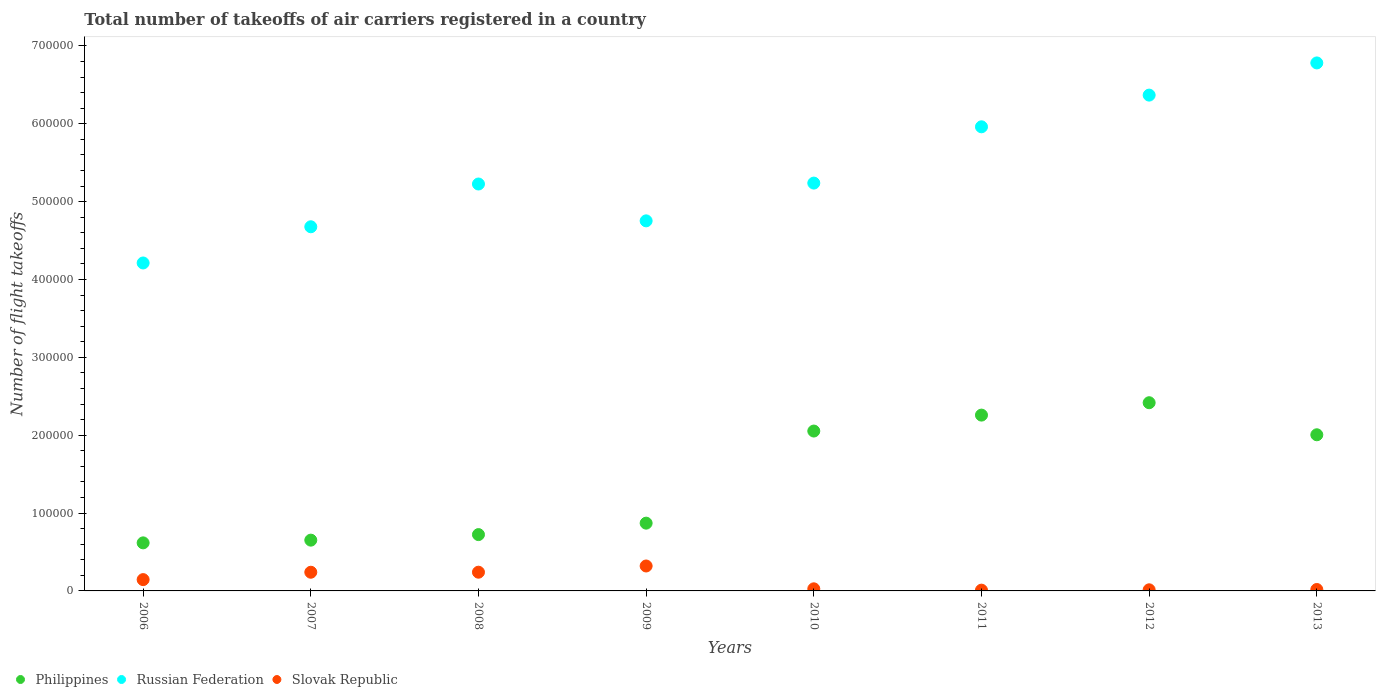How many different coloured dotlines are there?
Provide a succinct answer. 3. What is the total number of flight takeoffs in Philippines in 2013?
Ensure brevity in your answer.  2.01e+05. Across all years, what is the maximum total number of flight takeoffs in Philippines?
Offer a terse response. 2.42e+05. Across all years, what is the minimum total number of flight takeoffs in Slovak Republic?
Ensure brevity in your answer.  990. In which year was the total number of flight takeoffs in Russian Federation minimum?
Give a very brief answer. 2006. What is the total total number of flight takeoffs in Philippines in the graph?
Your response must be concise. 1.16e+06. What is the difference between the total number of flight takeoffs in Russian Federation in 2007 and that in 2009?
Ensure brevity in your answer.  -7591. What is the difference between the total number of flight takeoffs in Philippines in 2011 and the total number of flight takeoffs in Russian Federation in 2007?
Your answer should be compact. -2.42e+05. What is the average total number of flight takeoffs in Philippines per year?
Offer a very short reply. 1.45e+05. In the year 2009, what is the difference between the total number of flight takeoffs in Russian Federation and total number of flight takeoffs in Slovak Republic?
Your response must be concise. 4.43e+05. What is the ratio of the total number of flight takeoffs in Russian Federation in 2006 to that in 2007?
Keep it short and to the point. 0.9. Is the total number of flight takeoffs in Slovak Republic in 2009 less than that in 2013?
Make the answer very short. No. What is the difference between the highest and the second highest total number of flight takeoffs in Philippines?
Give a very brief answer. 1.59e+04. What is the difference between the highest and the lowest total number of flight takeoffs in Russian Federation?
Keep it short and to the point. 2.57e+05. In how many years, is the total number of flight takeoffs in Russian Federation greater than the average total number of flight takeoffs in Russian Federation taken over all years?
Your answer should be very brief. 3. Is it the case that in every year, the sum of the total number of flight takeoffs in Philippines and total number of flight takeoffs in Russian Federation  is greater than the total number of flight takeoffs in Slovak Republic?
Give a very brief answer. Yes. Is the total number of flight takeoffs in Philippines strictly greater than the total number of flight takeoffs in Russian Federation over the years?
Your answer should be very brief. No. Are the values on the major ticks of Y-axis written in scientific E-notation?
Your response must be concise. No. Does the graph contain any zero values?
Give a very brief answer. No. Does the graph contain grids?
Offer a terse response. No. Where does the legend appear in the graph?
Provide a short and direct response. Bottom left. How many legend labels are there?
Give a very brief answer. 3. How are the legend labels stacked?
Your answer should be very brief. Horizontal. What is the title of the graph?
Make the answer very short. Total number of takeoffs of air carriers registered in a country. Does "Papua New Guinea" appear as one of the legend labels in the graph?
Provide a succinct answer. No. What is the label or title of the Y-axis?
Provide a succinct answer. Number of flight takeoffs. What is the Number of flight takeoffs of Philippines in 2006?
Provide a succinct answer. 6.17e+04. What is the Number of flight takeoffs of Russian Federation in 2006?
Provide a succinct answer. 4.21e+05. What is the Number of flight takeoffs of Slovak Republic in 2006?
Keep it short and to the point. 1.45e+04. What is the Number of flight takeoffs in Philippines in 2007?
Provide a succinct answer. 6.52e+04. What is the Number of flight takeoffs in Russian Federation in 2007?
Make the answer very short. 4.68e+05. What is the Number of flight takeoffs of Slovak Republic in 2007?
Your answer should be compact. 2.40e+04. What is the Number of flight takeoffs of Philippines in 2008?
Ensure brevity in your answer.  7.23e+04. What is the Number of flight takeoffs in Russian Federation in 2008?
Keep it short and to the point. 5.23e+05. What is the Number of flight takeoffs of Slovak Republic in 2008?
Ensure brevity in your answer.  2.40e+04. What is the Number of flight takeoffs in Philippines in 2009?
Give a very brief answer. 8.70e+04. What is the Number of flight takeoffs of Russian Federation in 2009?
Provide a short and direct response. 4.75e+05. What is the Number of flight takeoffs of Slovak Republic in 2009?
Provide a succinct answer. 3.20e+04. What is the Number of flight takeoffs in Philippines in 2010?
Offer a very short reply. 2.05e+05. What is the Number of flight takeoffs in Russian Federation in 2010?
Offer a terse response. 5.24e+05. What is the Number of flight takeoffs in Slovak Republic in 2010?
Offer a terse response. 2702. What is the Number of flight takeoffs in Philippines in 2011?
Your response must be concise. 2.26e+05. What is the Number of flight takeoffs in Russian Federation in 2011?
Keep it short and to the point. 5.96e+05. What is the Number of flight takeoffs in Slovak Republic in 2011?
Your answer should be compact. 990. What is the Number of flight takeoffs in Philippines in 2012?
Keep it short and to the point. 2.42e+05. What is the Number of flight takeoffs of Russian Federation in 2012?
Offer a very short reply. 6.37e+05. What is the Number of flight takeoffs in Slovak Republic in 2012?
Make the answer very short. 1439. What is the Number of flight takeoffs in Philippines in 2013?
Provide a short and direct response. 2.01e+05. What is the Number of flight takeoffs in Russian Federation in 2013?
Offer a terse response. 6.78e+05. What is the Number of flight takeoffs in Slovak Republic in 2013?
Keep it short and to the point. 1816.45. Across all years, what is the maximum Number of flight takeoffs in Philippines?
Give a very brief answer. 2.42e+05. Across all years, what is the maximum Number of flight takeoffs of Russian Federation?
Give a very brief answer. 6.78e+05. Across all years, what is the maximum Number of flight takeoffs of Slovak Republic?
Offer a very short reply. 3.20e+04. Across all years, what is the minimum Number of flight takeoffs in Philippines?
Your response must be concise. 6.17e+04. Across all years, what is the minimum Number of flight takeoffs in Russian Federation?
Your response must be concise. 4.21e+05. Across all years, what is the minimum Number of flight takeoffs of Slovak Republic?
Provide a succinct answer. 990. What is the total Number of flight takeoffs in Philippines in the graph?
Your answer should be compact. 1.16e+06. What is the total Number of flight takeoffs of Russian Federation in the graph?
Your answer should be compact. 4.32e+06. What is the total Number of flight takeoffs of Slovak Republic in the graph?
Provide a short and direct response. 1.02e+05. What is the difference between the Number of flight takeoffs of Philippines in 2006 and that in 2007?
Offer a terse response. -3500. What is the difference between the Number of flight takeoffs of Russian Federation in 2006 and that in 2007?
Offer a very short reply. -4.65e+04. What is the difference between the Number of flight takeoffs of Slovak Republic in 2006 and that in 2007?
Offer a very short reply. -9476. What is the difference between the Number of flight takeoffs of Philippines in 2006 and that in 2008?
Make the answer very short. -1.06e+04. What is the difference between the Number of flight takeoffs in Russian Federation in 2006 and that in 2008?
Offer a terse response. -1.01e+05. What is the difference between the Number of flight takeoffs of Slovak Republic in 2006 and that in 2008?
Make the answer very short. -9523. What is the difference between the Number of flight takeoffs of Philippines in 2006 and that in 2009?
Offer a terse response. -2.53e+04. What is the difference between the Number of flight takeoffs of Russian Federation in 2006 and that in 2009?
Ensure brevity in your answer.  -5.41e+04. What is the difference between the Number of flight takeoffs of Slovak Republic in 2006 and that in 2009?
Your answer should be compact. -1.75e+04. What is the difference between the Number of flight takeoffs in Philippines in 2006 and that in 2010?
Make the answer very short. -1.44e+05. What is the difference between the Number of flight takeoffs of Russian Federation in 2006 and that in 2010?
Offer a terse response. -1.03e+05. What is the difference between the Number of flight takeoffs in Slovak Republic in 2006 and that in 2010?
Keep it short and to the point. 1.18e+04. What is the difference between the Number of flight takeoffs of Philippines in 2006 and that in 2011?
Your answer should be very brief. -1.64e+05. What is the difference between the Number of flight takeoffs in Russian Federation in 2006 and that in 2011?
Give a very brief answer. -1.75e+05. What is the difference between the Number of flight takeoffs in Slovak Republic in 2006 and that in 2011?
Your response must be concise. 1.35e+04. What is the difference between the Number of flight takeoffs in Philippines in 2006 and that in 2012?
Ensure brevity in your answer.  -1.80e+05. What is the difference between the Number of flight takeoffs in Russian Federation in 2006 and that in 2012?
Your answer should be compact. -2.16e+05. What is the difference between the Number of flight takeoffs in Slovak Republic in 2006 and that in 2012?
Provide a succinct answer. 1.31e+04. What is the difference between the Number of flight takeoffs in Philippines in 2006 and that in 2013?
Provide a short and direct response. -1.39e+05. What is the difference between the Number of flight takeoffs of Russian Federation in 2006 and that in 2013?
Offer a very short reply. -2.57e+05. What is the difference between the Number of flight takeoffs of Slovak Republic in 2006 and that in 2013?
Give a very brief answer. 1.27e+04. What is the difference between the Number of flight takeoffs in Philippines in 2007 and that in 2008?
Your response must be concise. -7121. What is the difference between the Number of flight takeoffs in Russian Federation in 2007 and that in 2008?
Your response must be concise. -5.49e+04. What is the difference between the Number of flight takeoffs of Slovak Republic in 2007 and that in 2008?
Offer a very short reply. -47. What is the difference between the Number of flight takeoffs in Philippines in 2007 and that in 2009?
Make the answer very short. -2.18e+04. What is the difference between the Number of flight takeoffs in Russian Federation in 2007 and that in 2009?
Offer a terse response. -7591. What is the difference between the Number of flight takeoffs of Slovak Republic in 2007 and that in 2009?
Ensure brevity in your answer.  -8023. What is the difference between the Number of flight takeoffs of Philippines in 2007 and that in 2010?
Ensure brevity in your answer.  -1.40e+05. What is the difference between the Number of flight takeoffs of Russian Federation in 2007 and that in 2010?
Offer a very short reply. -5.61e+04. What is the difference between the Number of flight takeoffs of Slovak Republic in 2007 and that in 2010?
Your answer should be compact. 2.13e+04. What is the difference between the Number of flight takeoffs in Philippines in 2007 and that in 2011?
Keep it short and to the point. -1.61e+05. What is the difference between the Number of flight takeoffs in Russian Federation in 2007 and that in 2011?
Your answer should be very brief. -1.28e+05. What is the difference between the Number of flight takeoffs in Slovak Republic in 2007 and that in 2011?
Keep it short and to the point. 2.30e+04. What is the difference between the Number of flight takeoffs in Philippines in 2007 and that in 2012?
Offer a terse response. -1.76e+05. What is the difference between the Number of flight takeoffs of Russian Federation in 2007 and that in 2012?
Ensure brevity in your answer.  -1.69e+05. What is the difference between the Number of flight takeoffs of Slovak Republic in 2007 and that in 2012?
Give a very brief answer. 2.26e+04. What is the difference between the Number of flight takeoffs of Philippines in 2007 and that in 2013?
Give a very brief answer. -1.35e+05. What is the difference between the Number of flight takeoffs in Russian Federation in 2007 and that in 2013?
Give a very brief answer. -2.10e+05. What is the difference between the Number of flight takeoffs in Slovak Republic in 2007 and that in 2013?
Provide a short and direct response. 2.22e+04. What is the difference between the Number of flight takeoffs of Philippines in 2008 and that in 2009?
Your answer should be very brief. -1.47e+04. What is the difference between the Number of flight takeoffs in Russian Federation in 2008 and that in 2009?
Offer a very short reply. 4.73e+04. What is the difference between the Number of flight takeoffs in Slovak Republic in 2008 and that in 2009?
Provide a succinct answer. -7976. What is the difference between the Number of flight takeoffs in Philippines in 2008 and that in 2010?
Provide a short and direct response. -1.33e+05. What is the difference between the Number of flight takeoffs in Russian Federation in 2008 and that in 2010?
Make the answer very short. -1182. What is the difference between the Number of flight takeoffs of Slovak Republic in 2008 and that in 2010?
Ensure brevity in your answer.  2.13e+04. What is the difference between the Number of flight takeoffs of Philippines in 2008 and that in 2011?
Ensure brevity in your answer.  -1.53e+05. What is the difference between the Number of flight takeoffs of Russian Federation in 2008 and that in 2011?
Offer a very short reply. -7.35e+04. What is the difference between the Number of flight takeoffs of Slovak Republic in 2008 and that in 2011?
Offer a very short reply. 2.31e+04. What is the difference between the Number of flight takeoffs of Philippines in 2008 and that in 2012?
Provide a succinct answer. -1.69e+05. What is the difference between the Number of flight takeoffs of Russian Federation in 2008 and that in 2012?
Your response must be concise. -1.14e+05. What is the difference between the Number of flight takeoffs of Slovak Republic in 2008 and that in 2012?
Offer a terse response. 2.26e+04. What is the difference between the Number of flight takeoffs of Philippines in 2008 and that in 2013?
Give a very brief answer. -1.28e+05. What is the difference between the Number of flight takeoffs in Russian Federation in 2008 and that in 2013?
Give a very brief answer. -1.55e+05. What is the difference between the Number of flight takeoffs of Slovak Republic in 2008 and that in 2013?
Provide a short and direct response. 2.22e+04. What is the difference between the Number of flight takeoffs of Philippines in 2009 and that in 2010?
Your answer should be compact. -1.18e+05. What is the difference between the Number of flight takeoffs of Russian Federation in 2009 and that in 2010?
Offer a terse response. -4.85e+04. What is the difference between the Number of flight takeoffs of Slovak Republic in 2009 and that in 2010?
Your response must be concise. 2.93e+04. What is the difference between the Number of flight takeoffs in Philippines in 2009 and that in 2011?
Make the answer very short. -1.39e+05. What is the difference between the Number of flight takeoffs in Russian Federation in 2009 and that in 2011?
Provide a succinct answer. -1.21e+05. What is the difference between the Number of flight takeoffs in Slovak Republic in 2009 and that in 2011?
Make the answer very short. 3.10e+04. What is the difference between the Number of flight takeoffs in Philippines in 2009 and that in 2012?
Keep it short and to the point. -1.55e+05. What is the difference between the Number of flight takeoffs in Russian Federation in 2009 and that in 2012?
Provide a succinct answer. -1.61e+05. What is the difference between the Number of flight takeoffs in Slovak Republic in 2009 and that in 2012?
Your response must be concise. 3.06e+04. What is the difference between the Number of flight takeoffs in Philippines in 2009 and that in 2013?
Give a very brief answer. -1.14e+05. What is the difference between the Number of flight takeoffs in Russian Federation in 2009 and that in 2013?
Your answer should be very brief. -2.03e+05. What is the difference between the Number of flight takeoffs of Slovak Republic in 2009 and that in 2013?
Offer a terse response. 3.02e+04. What is the difference between the Number of flight takeoffs of Philippines in 2010 and that in 2011?
Your answer should be compact. -2.05e+04. What is the difference between the Number of flight takeoffs in Russian Federation in 2010 and that in 2011?
Make the answer very short. -7.23e+04. What is the difference between the Number of flight takeoffs of Slovak Republic in 2010 and that in 2011?
Offer a terse response. 1712. What is the difference between the Number of flight takeoffs of Philippines in 2010 and that in 2012?
Keep it short and to the point. -3.64e+04. What is the difference between the Number of flight takeoffs of Russian Federation in 2010 and that in 2012?
Provide a short and direct response. -1.13e+05. What is the difference between the Number of flight takeoffs in Slovak Republic in 2010 and that in 2012?
Provide a succinct answer. 1263. What is the difference between the Number of flight takeoffs in Philippines in 2010 and that in 2013?
Make the answer very short. 4782.3. What is the difference between the Number of flight takeoffs in Russian Federation in 2010 and that in 2013?
Your answer should be very brief. -1.54e+05. What is the difference between the Number of flight takeoffs of Slovak Republic in 2010 and that in 2013?
Provide a short and direct response. 885.55. What is the difference between the Number of flight takeoffs in Philippines in 2011 and that in 2012?
Your answer should be very brief. -1.59e+04. What is the difference between the Number of flight takeoffs of Russian Federation in 2011 and that in 2012?
Make the answer very short. -4.07e+04. What is the difference between the Number of flight takeoffs of Slovak Republic in 2011 and that in 2012?
Offer a very short reply. -449. What is the difference between the Number of flight takeoffs of Philippines in 2011 and that in 2013?
Your response must be concise. 2.53e+04. What is the difference between the Number of flight takeoffs of Russian Federation in 2011 and that in 2013?
Your answer should be compact. -8.20e+04. What is the difference between the Number of flight takeoffs in Slovak Republic in 2011 and that in 2013?
Provide a short and direct response. -826.45. What is the difference between the Number of flight takeoffs in Philippines in 2012 and that in 2013?
Provide a short and direct response. 4.12e+04. What is the difference between the Number of flight takeoffs in Russian Federation in 2012 and that in 2013?
Offer a very short reply. -4.13e+04. What is the difference between the Number of flight takeoffs in Slovak Republic in 2012 and that in 2013?
Keep it short and to the point. -377.45. What is the difference between the Number of flight takeoffs of Philippines in 2006 and the Number of flight takeoffs of Russian Federation in 2007?
Your answer should be compact. -4.06e+05. What is the difference between the Number of flight takeoffs of Philippines in 2006 and the Number of flight takeoffs of Slovak Republic in 2007?
Offer a terse response. 3.77e+04. What is the difference between the Number of flight takeoffs in Russian Federation in 2006 and the Number of flight takeoffs in Slovak Republic in 2007?
Your answer should be very brief. 3.97e+05. What is the difference between the Number of flight takeoffs of Philippines in 2006 and the Number of flight takeoffs of Russian Federation in 2008?
Your response must be concise. -4.61e+05. What is the difference between the Number of flight takeoffs in Philippines in 2006 and the Number of flight takeoffs in Slovak Republic in 2008?
Give a very brief answer. 3.77e+04. What is the difference between the Number of flight takeoffs of Russian Federation in 2006 and the Number of flight takeoffs of Slovak Republic in 2008?
Provide a succinct answer. 3.97e+05. What is the difference between the Number of flight takeoffs of Philippines in 2006 and the Number of flight takeoffs of Russian Federation in 2009?
Your response must be concise. -4.14e+05. What is the difference between the Number of flight takeoffs in Philippines in 2006 and the Number of flight takeoffs in Slovak Republic in 2009?
Your answer should be very brief. 2.97e+04. What is the difference between the Number of flight takeoffs of Russian Federation in 2006 and the Number of flight takeoffs of Slovak Republic in 2009?
Make the answer very short. 3.89e+05. What is the difference between the Number of flight takeoffs of Philippines in 2006 and the Number of flight takeoffs of Russian Federation in 2010?
Offer a very short reply. -4.62e+05. What is the difference between the Number of flight takeoffs of Philippines in 2006 and the Number of flight takeoffs of Slovak Republic in 2010?
Provide a short and direct response. 5.90e+04. What is the difference between the Number of flight takeoffs of Russian Federation in 2006 and the Number of flight takeoffs of Slovak Republic in 2010?
Ensure brevity in your answer.  4.18e+05. What is the difference between the Number of flight takeoffs of Philippines in 2006 and the Number of flight takeoffs of Russian Federation in 2011?
Your answer should be compact. -5.34e+05. What is the difference between the Number of flight takeoffs of Philippines in 2006 and the Number of flight takeoffs of Slovak Republic in 2011?
Your answer should be compact. 6.07e+04. What is the difference between the Number of flight takeoffs of Russian Federation in 2006 and the Number of flight takeoffs of Slovak Republic in 2011?
Your answer should be very brief. 4.20e+05. What is the difference between the Number of flight takeoffs in Philippines in 2006 and the Number of flight takeoffs in Russian Federation in 2012?
Offer a very short reply. -5.75e+05. What is the difference between the Number of flight takeoffs in Philippines in 2006 and the Number of flight takeoffs in Slovak Republic in 2012?
Ensure brevity in your answer.  6.03e+04. What is the difference between the Number of flight takeoffs in Russian Federation in 2006 and the Number of flight takeoffs in Slovak Republic in 2012?
Your answer should be compact. 4.20e+05. What is the difference between the Number of flight takeoffs in Philippines in 2006 and the Number of flight takeoffs in Russian Federation in 2013?
Provide a succinct answer. -6.16e+05. What is the difference between the Number of flight takeoffs of Philippines in 2006 and the Number of flight takeoffs of Slovak Republic in 2013?
Give a very brief answer. 5.99e+04. What is the difference between the Number of flight takeoffs of Russian Federation in 2006 and the Number of flight takeoffs of Slovak Republic in 2013?
Offer a terse response. 4.19e+05. What is the difference between the Number of flight takeoffs of Philippines in 2007 and the Number of flight takeoffs of Russian Federation in 2008?
Your response must be concise. -4.57e+05. What is the difference between the Number of flight takeoffs in Philippines in 2007 and the Number of flight takeoffs in Slovak Republic in 2008?
Provide a succinct answer. 4.12e+04. What is the difference between the Number of flight takeoffs in Russian Federation in 2007 and the Number of flight takeoffs in Slovak Republic in 2008?
Your response must be concise. 4.44e+05. What is the difference between the Number of flight takeoffs in Philippines in 2007 and the Number of flight takeoffs in Russian Federation in 2009?
Your answer should be very brief. -4.10e+05. What is the difference between the Number of flight takeoffs in Philippines in 2007 and the Number of flight takeoffs in Slovak Republic in 2009?
Your response must be concise. 3.32e+04. What is the difference between the Number of flight takeoffs of Russian Federation in 2007 and the Number of flight takeoffs of Slovak Republic in 2009?
Give a very brief answer. 4.36e+05. What is the difference between the Number of flight takeoffs in Philippines in 2007 and the Number of flight takeoffs in Russian Federation in 2010?
Ensure brevity in your answer.  -4.59e+05. What is the difference between the Number of flight takeoffs in Philippines in 2007 and the Number of flight takeoffs in Slovak Republic in 2010?
Offer a very short reply. 6.25e+04. What is the difference between the Number of flight takeoffs of Russian Federation in 2007 and the Number of flight takeoffs of Slovak Republic in 2010?
Keep it short and to the point. 4.65e+05. What is the difference between the Number of flight takeoffs in Philippines in 2007 and the Number of flight takeoffs in Russian Federation in 2011?
Provide a short and direct response. -5.31e+05. What is the difference between the Number of flight takeoffs in Philippines in 2007 and the Number of flight takeoffs in Slovak Republic in 2011?
Ensure brevity in your answer.  6.42e+04. What is the difference between the Number of flight takeoffs of Russian Federation in 2007 and the Number of flight takeoffs of Slovak Republic in 2011?
Provide a succinct answer. 4.67e+05. What is the difference between the Number of flight takeoffs in Philippines in 2007 and the Number of flight takeoffs in Russian Federation in 2012?
Offer a very short reply. -5.72e+05. What is the difference between the Number of flight takeoffs of Philippines in 2007 and the Number of flight takeoffs of Slovak Republic in 2012?
Provide a short and direct response. 6.38e+04. What is the difference between the Number of flight takeoffs of Russian Federation in 2007 and the Number of flight takeoffs of Slovak Republic in 2012?
Provide a short and direct response. 4.66e+05. What is the difference between the Number of flight takeoffs of Philippines in 2007 and the Number of flight takeoffs of Russian Federation in 2013?
Your answer should be very brief. -6.13e+05. What is the difference between the Number of flight takeoffs in Philippines in 2007 and the Number of flight takeoffs in Slovak Republic in 2013?
Provide a succinct answer. 6.34e+04. What is the difference between the Number of flight takeoffs of Russian Federation in 2007 and the Number of flight takeoffs of Slovak Republic in 2013?
Provide a succinct answer. 4.66e+05. What is the difference between the Number of flight takeoffs in Philippines in 2008 and the Number of flight takeoffs in Russian Federation in 2009?
Your response must be concise. -4.03e+05. What is the difference between the Number of flight takeoffs of Philippines in 2008 and the Number of flight takeoffs of Slovak Republic in 2009?
Your response must be concise. 4.03e+04. What is the difference between the Number of flight takeoffs in Russian Federation in 2008 and the Number of flight takeoffs in Slovak Republic in 2009?
Make the answer very short. 4.91e+05. What is the difference between the Number of flight takeoffs in Philippines in 2008 and the Number of flight takeoffs in Russian Federation in 2010?
Your answer should be compact. -4.51e+05. What is the difference between the Number of flight takeoffs in Philippines in 2008 and the Number of flight takeoffs in Slovak Republic in 2010?
Give a very brief answer. 6.96e+04. What is the difference between the Number of flight takeoffs in Russian Federation in 2008 and the Number of flight takeoffs in Slovak Republic in 2010?
Offer a terse response. 5.20e+05. What is the difference between the Number of flight takeoffs in Philippines in 2008 and the Number of flight takeoffs in Russian Federation in 2011?
Offer a terse response. -5.24e+05. What is the difference between the Number of flight takeoffs of Philippines in 2008 and the Number of flight takeoffs of Slovak Republic in 2011?
Offer a very short reply. 7.13e+04. What is the difference between the Number of flight takeoffs in Russian Federation in 2008 and the Number of flight takeoffs in Slovak Republic in 2011?
Your answer should be compact. 5.22e+05. What is the difference between the Number of flight takeoffs in Philippines in 2008 and the Number of flight takeoffs in Russian Federation in 2012?
Offer a terse response. -5.64e+05. What is the difference between the Number of flight takeoffs of Philippines in 2008 and the Number of flight takeoffs of Slovak Republic in 2012?
Keep it short and to the point. 7.09e+04. What is the difference between the Number of flight takeoffs of Russian Federation in 2008 and the Number of flight takeoffs of Slovak Republic in 2012?
Provide a succinct answer. 5.21e+05. What is the difference between the Number of flight takeoffs of Philippines in 2008 and the Number of flight takeoffs of Russian Federation in 2013?
Provide a short and direct response. -6.06e+05. What is the difference between the Number of flight takeoffs in Philippines in 2008 and the Number of flight takeoffs in Slovak Republic in 2013?
Your response must be concise. 7.05e+04. What is the difference between the Number of flight takeoffs in Russian Federation in 2008 and the Number of flight takeoffs in Slovak Republic in 2013?
Your response must be concise. 5.21e+05. What is the difference between the Number of flight takeoffs in Philippines in 2009 and the Number of flight takeoffs in Russian Federation in 2010?
Provide a short and direct response. -4.37e+05. What is the difference between the Number of flight takeoffs of Philippines in 2009 and the Number of flight takeoffs of Slovak Republic in 2010?
Your answer should be very brief. 8.43e+04. What is the difference between the Number of flight takeoffs of Russian Federation in 2009 and the Number of flight takeoffs of Slovak Republic in 2010?
Your answer should be compact. 4.73e+05. What is the difference between the Number of flight takeoffs in Philippines in 2009 and the Number of flight takeoffs in Russian Federation in 2011?
Your answer should be compact. -5.09e+05. What is the difference between the Number of flight takeoffs of Philippines in 2009 and the Number of flight takeoffs of Slovak Republic in 2011?
Offer a very short reply. 8.60e+04. What is the difference between the Number of flight takeoffs in Russian Federation in 2009 and the Number of flight takeoffs in Slovak Republic in 2011?
Your answer should be very brief. 4.74e+05. What is the difference between the Number of flight takeoffs of Philippines in 2009 and the Number of flight takeoffs of Russian Federation in 2012?
Provide a short and direct response. -5.50e+05. What is the difference between the Number of flight takeoffs of Philippines in 2009 and the Number of flight takeoffs of Slovak Republic in 2012?
Provide a short and direct response. 8.56e+04. What is the difference between the Number of flight takeoffs of Russian Federation in 2009 and the Number of flight takeoffs of Slovak Republic in 2012?
Your answer should be very brief. 4.74e+05. What is the difference between the Number of flight takeoffs in Philippines in 2009 and the Number of flight takeoffs in Russian Federation in 2013?
Provide a succinct answer. -5.91e+05. What is the difference between the Number of flight takeoffs in Philippines in 2009 and the Number of flight takeoffs in Slovak Republic in 2013?
Offer a terse response. 8.52e+04. What is the difference between the Number of flight takeoffs in Russian Federation in 2009 and the Number of flight takeoffs in Slovak Republic in 2013?
Your answer should be very brief. 4.73e+05. What is the difference between the Number of flight takeoffs of Philippines in 2010 and the Number of flight takeoffs of Russian Federation in 2011?
Provide a short and direct response. -3.91e+05. What is the difference between the Number of flight takeoffs in Philippines in 2010 and the Number of flight takeoffs in Slovak Republic in 2011?
Your answer should be very brief. 2.04e+05. What is the difference between the Number of flight takeoffs of Russian Federation in 2010 and the Number of flight takeoffs of Slovak Republic in 2011?
Keep it short and to the point. 5.23e+05. What is the difference between the Number of flight takeoffs in Philippines in 2010 and the Number of flight takeoffs in Russian Federation in 2012?
Provide a short and direct response. -4.31e+05. What is the difference between the Number of flight takeoffs of Philippines in 2010 and the Number of flight takeoffs of Slovak Republic in 2012?
Your answer should be compact. 2.04e+05. What is the difference between the Number of flight takeoffs in Russian Federation in 2010 and the Number of flight takeoffs in Slovak Republic in 2012?
Your answer should be compact. 5.22e+05. What is the difference between the Number of flight takeoffs of Philippines in 2010 and the Number of flight takeoffs of Russian Federation in 2013?
Your response must be concise. -4.73e+05. What is the difference between the Number of flight takeoffs in Philippines in 2010 and the Number of flight takeoffs in Slovak Republic in 2013?
Provide a short and direct response. 2.04e+05. What is the difference between the Number of flight takeoffs of Russian Federation in 2010 and the Number of flight takeoffs of Slovak Republic in 2013?
Offer a terse response. 5.22e+05. What is the difference between the Number of flight takeoffs in Philippines in 2011 and the Number of flight takeoffs in Russian Federation in 2012?
Make the answer very short. -4.11e+05. What is the difference between the Number of flight takeoffs in Philippines in 2011 and the Number of flight takeoffs in Slovak Republic in 2012?
Make the answer very short. 2.24e+05. What is the difference between the Number of flight takeoffs in Russian Federation in 2011 and the Number of flight takeoffs in Slovak Republic in 2012?
Ensure brevity in your answer.  5.95e+05. What is the difference between the Number of flight takeoffs of Philippines in 2011 and the Number of flight takeoffs of Russian Federation in 2013?
Provide a short and direct response. -4.52e+05. What is the difference between the Number of flight takeoffs in Philippines in 2011 and the Number of flight takeoffs in Slovak Republic in 2013?
Offer a very short reply. 2.24e+05. What is the difference between the Number of flight takeoffs in Russian Federation in 2011 and the Number of flight takeoffs in Slovak Republic in 2013?
Offer a terse response. 5.94e+05. What is the difference between the Number of flight takeoffs in Philippines in 2012 and the Number of flight takeoffs in Russian Federation in 2013?
Keep it short and to the point. -4.36e+05. What is the difference between the Number of flight takeoffs in Philippines in 2012 and the Number of flight takeoffs in Slovak Republic in 2013?
Provide a short and direct response. 2.40e+05. What is the difference between the Number of flight takeoffs of Russian Federation in 2012 and the Number of flight takeoffs of Slovak Republic in 2013?
Keep it short and to the point. 6.35e+05. What is the average Number of flight takeoffs in Philippines per year?
Your answer should be very brief. 1.45e+05. What is the average Number of flight takeoffs of Russian Federation per year?
Your answer should be compact. 5.40e+05. What is the average Number of flight takeoffs of Slovak Republic per year?
Your answer should be compact. 1.27e+04. In the year 2006, what is the difference between the Number of flight takeoffs of Philippines and Number of flight takeoffs of Russian Federation?
Offer a very short reply. -3.59e+05. In the year 2006, what is the difference between the Number of flight takeoffs of Philippines and Number of flight takeoffs of Slovak Republic?
Make the answer very short. 4.72e+04. In the year 2006, what is the difference between the Number of flight takeoffs of Russian Federation and Number of flight takeoffs of Slovak Republic?
Give a very brief answer. 4.07e+05. In the year 2007, what is the difference between the Number of flight takeoffs of Philippines and Number of flight takeoffs of Russian Federation?
Your answer should be compact. -4.02e+05. In the year 2007, what is the difference between the Number of flight takeoffs in Philippines and Number of flight takeoffs in Slovak Republic?
Keep it short and to the point. 4.12e+04. In the year 2007, what is the difference between the Number of flight takeoffs of Russian Federation and Number of flight takeoffs of Slovak Republic?
Keep it short and to the point. 4.44e+05. In the year 2008, what is the difference between the Number of flight takeoffs in Philippines and Number of flight takeoffs in Russian Federation?
Ensure brevity in your answer.  -4.50e+05. In the year 2008, what is the difference between the Number of flight takeoffs of Philippines and Number of flight takeoffs of Slovak Republic?
Your answer should be compact. 4.83e+04. In the year 2008, what is the difference between the Number of flight takeoffs in Russian Federation and Number of flight takeoffs in Slovak Republic?
Your answer should be compact. 4.99e+05. In the year 2009, what is the difference between the Number of flight takeoffs in Philippines and Number of flight takeoffs in Russian Federation?
Make the answer very short. -3.88e+05. In the year 2009, what is the difference between the Number of flight takeoffs in Philippines and Number of flight takeoffs in Slovak Republic?
Provide a short and direct response. 5.50e+04. In the year 2009, what is the difference between the Number of flight takeoffs of Russian Federation and Number of flight takeoffs of Slovak Republic?
Offer a terse response. 4.43e+05. In the year 2010, what is the difference between the Number of flight takeoffs of Philippines and Number of flight takeoffs of Russian Federation?
Your response must be concise. -3.18e+05. In the year 2010, what is the difference between the Number of flight takeoffs of Philippines and Number of flight takeoffs of Slovak Republic?
Provide a succinct answer. 2.03e+05. In the year 2010, what is the difference between the Number of flight takeoffs in Russian Federation and Number of flight takeoffs in Slovak Republic?
Your answer should be compact. 5.21e+05. In the year 2011, what is the difference between the Number of flight takeoffs of Philippines and Number of flight takeoffs of Russian Federation?
Offer a terse response. -3.70e+05. In the year 2011, what is the difference between the Number of flight takeoffs of Philippines and Number of flight takeoffs of Slovak Republic?
Keep it short and to the point. 2.25e+05. In the year 2011, what is the difference between the Number of flight takeoffs in Russian Federation and Number of flight takeoffs in Slovak Republic?
Your answer should be very brief. 5.95e+05. In the year 2012, what is the difference between the Number of flight takeoffs of Philippines and Number of flight takeoffs of Russian Federation?
Your answer should be very brief. -3.95e+05. In the year 2012, what is the difference between the Number of flight takeoffs of Philippines and Number of flight takeoffs of Slovak Republic?
Make the answer very short. 2.40e+05. In the year 2012, what is the difference between the Number of flight takeoffs of Russian Federation and Number of flight takeoffs of Slovak Republic?
Offer a very short reply. 6.35e+05. In the year 2013, what is the difference between the Number of flight takeoffs of Philippines and Number of flight takeoffs of Russian Federation?
Offer a terse response. -4.78e+05. In the year 2013, what is the difference between the Number of flight takeoffs of Philippines and Number of flight takeoffs of Slovak Republic?
Give a very brief answer. 1.99e+05. In the year 2013, what is the difference between the Number of flight takeoffs of Russian Federation and Number of flight takeoffs of Slovak Republic?
Your answer should be compact. 6.76e+05. What is the ratio of the Number of flight takeoffs in Philippines in 2006 to that in 2007?
Provide a succinct answer. 0.95. What is the ratio of the Number of flight takeoffs of Russian Federation in 2006 to that in 2007?
Give a very brief answer. 0.9. What is the ratio of the Number of flight takeoffs in Slovak Republic in 2006 to that in 2007?
Provide a succinct answer. 0.61. What is the ratio of the Number of flight takeoffs in Philippines in 2006 to that in 2008?
Your answer should be compact. 0.85. What is the ratio of the Number of flight takeoffs of Russian Federation in 2006 to that in 2008?
Your answer should be very brief. 0.81. What is the ratio of the Number of flight takeoffs of Slovak Republic in 2006 to that in 2008?
Your answer should be very brief. 0.6. What is the ratio of the Number of flight takeoffs of Philippines in 2006 to that in 2009?
Your answer should be compact. 0.71. What is the ratio of the Number of flight takeoffs in Russian Federation in 2006 to that in 2009?
Offer a very short reply. 0.89. What is the ratio of the Number of flight takeoffs in Slovak Republic in 2006 to that in 2009?
Ensure brevity in your answer.  0.45. What is the ratio of the Number of flight takeoffs of Philippines in 2006 to that in 2010?
Provide a succinct answer. 0.3. What is the ratio of the Number of flight takeoffs of Russian Federation in 2006 to that in 2010?
Offer a terse response. 0.8. What is the ratio of the Number of flight takeoffs in Slovak Republic in 2006 to that in 2010?
Offer a very short reply. 5.37. What is the ratio of the Number of flight takeoffs of Philippines in 2006 to that in 2011?
Keep it short and to the point. 0.27. What is the ratio of the Number of flight takeoffs of Russian Federation in 2006 to that in 2011?
Offer a terse response. 0.71. What is the ratio of the Number of flight takeoffs in Slovak Republic in 2006 to that in 2011?
Your response must be concise. 14.67. What is the ratio of the Number of flight takeoffs of Philippines in 2006 to that in 2012?
Your answer should be compact. 0.26. What is the ratio of the Number of flight takeoffs of Russian Federation in 2006 to that in 2012?
Your answer should be compact. 0.66. What is the ratio of the Number of flight takeoffs of Slovak Republic in 2006 to that in 2012?
Make the answer very short. 10.09. What is the ratio of the Number of flight takeoffs in Philippines in 2006 to that in 2013?
Keep it short and to the point. 0.31. What is the ratio of the Number of flight takeoffs in Russian Federation in 2006 to that in 2013?
Ensure brevity in your answer.  0.62. What is the ratio of the Number of flight takeoffs of Slovak Republic in 2006 to that in 2013?
Ensure brevity in your answer.  7.99. What is the ratio of the Number of flight takeoffs in Philippines in 2007 to that in 2008?
Keep it short and to the point. 0.9. What is the ratio of the Number of flight takeoffs of Russian Federation in 2007 to that in 2008?
Make the answer very short. 0.89. What is the ratio of the Number of flight takeoffs of Slovak Republic in 2007 to that in 2008?
Provide a succinct answer. 1. What is the ratio of the Number of flight takeoffs in Philippines in 2007 to that in 2009?
Make the answer very short. 0.75. What is the ratio of the Number of flight takeoffs in Russian Federation in 2007 to that in 2009?
Give a very brief answer. 0.98. What is the ratio of the Number of flight takeoffs in Slovak Republic in 2007 to that in 2009?
Offer a terse response. 0.75. What is the ratio of the Number of flight takeoffs of Philippines in 2007 to that in 2010?
Ensure brevity in your answer.  0.32. What is the ratio of the Number of flight takeoffs in Russian Federation in 2007 to that in 2010?
Your response must be concise. 0.89. What is the ratio of the Number of flight takeoffs in Slovak Republic in 2007 to that in 2010?
Your answer should be very brief. 8.88. What is the ratio of the Number of flight takeoffs of Philippines in 2007 to that in 2011?
Your answer should be compact. 0.29. What is the ratio of the Number of flight takeoffs of Russian Federation in 2007 to that in 2011?
Offer a terse response. 0.78. What is the ratio of the Number of flight takeoffs in Slovak Republic in 2007 to that in 2011?
Offer a very short reply. 24.24. What is the ratio of the Number of flight takeoffs of Philippines in 2007 to that in 2012?
Provide a succinct answer. 0.27. What is the ratio of the Number of flight takeoffs in Russian Federation in 2007 to that in 2012?
Your answer should be compact. 0.73. What is the ratio of the Number of flight takeoffs in Slovak Republic in 2007 to that in 2012?
Your response must be concise. 16.68. What is the ratio of the Number of flight takeoffs in Philippines in 2007 to that in 2013?
Your response must be concise. 0.33. What is the ratio of the Number of flight takeoffs of Russian Federation in 2007 to that in 2013?
Offer a terse response. 0.69. What is the ratio of the Number of flight takeoffs in Slovak Republic in 2007 to that in 2013?
Make the answer very short. 13.21. What is the ratio of the Number of flight takeoffs of Philippines in 2008 to that in 2009?
Ensure brevity in your answer.  0.83. What is the ratio of the Number of flight takeoffs in Russian Federation in 2008 to that in 2009?
Your answer should be compact. 1.1. What is the ratio of the Number of flight takeoffs in Slovak Republic in 2008 to that in 2009?
Give a very brief answer. 0.75. What is the ratio of the Number of flight takeoffs in Philippines in 2008 to that in 2010?
Your answer should be very brief. 0.35. What is the ratio of the Number of flight takeoffs in Russian Federation in 2008 to that in 2010?
Your answer should be very brief. 1. What is the ratio of the Number of flight takeoffs in Slovak Republic in 2008 to that in 2010?
Ensure brevity in your answer.  8.9. What is the ratio of the Number of flight takeoffs in Philippines in 2008 to that in 2011?
Your response must be concise. 0.32. What is the ratio of the Number of flight takeoffs in Russian Federation in 2008 to that in 2011?
Make the answer very short. 0.88. What is the ratio of the Number of flight takeoffs in Slovak Republic in 2008 to that in 2011?
Give a very brief answer. 24.29. What is the ratio of the Number of flight takeoffs in Philippines in 2008 to that in 2012?
Your answer should be very brief. 0.3. What is the ratio of the Number of flight takeoffs in Russian Federation in 2008 to that in 2012?
Provide a succinct answer. 0.82. What is the ratio of the Number of flight takeoffs in Slovak Republic in 2008 to that in 2012?
Provide a succinct answer. 16.71. What is the ratio of the Number of flight takeoffs of Philippines in 2008 to that in 2013?
Offer a very short reply. 0.36. What is the ratio of the Number of flight takeoffs in Russian Federation in 2008 to that in 2013?
Offer a terse response. 0.77. What is the ratio of the Number of flight takeoffs of Slovak Republic in 2008 to that in 2013?
Give a very brief answer. 13.24. What is the ratio of the Number of flight takeoffs in Philippines in 2009 to that in 2010?
Your answer should be very brief. 0.42. What is the ratio of the Number of flight takeoffs in Russian Federation in 2009 to that in 2010?
Your answer should be very brief. 0.91. What is the ratio of the Number of flight takeoffs of Slovak Republic in 2009 to that in 2010?
Make the answer very short. 11.85. What is the ratio of the Number of flight takeoffs in Philippines in 2009 to that in 2011?
Make the answer very short. 0.39. What is the ratio of the Number of flight takeoffs in Russian Federation in 2009 to that in 2011?
Give a very brief answer. 0.8. What is the ratio of the Number of flight takeoffs in Slovak Republic in 2009 to that in 2011?
Your answer should be compact. 32.34. What is the ratio of the Number of flight takeoffs of Philippines in 2009 to that in 2012?
Make the answer very short. 0.36. What is the ratio of the Number of flight takeoffs of Russian Federation in 2009 to that in 2012?
Your answer should be compact. 0.75. What is the ratio of the Number of flight takeoffs in Slovak Republic in 2009 to that in 2012?
Your response must be concise. 22.25. What is the ratio of the Number of flight takeoffs in Philippines in 2009 to that in 2013?
Offer a very short reply. 0.43. What is the ratio of the Number of flight takeoffs of Russian Federation in 2009 to that in 2013?
Ensure brevity in your answer.  0.7. What is the ratio of the Number of flight takeoffs of Slovak Republic in 2009 to that in 2013?
Give a very brief answer. 17.63. What is the ratio of the Number of flight takeoffs in Philippines in 2010 to that in 2011?
Give a very brief answer. 0.91. What is the ratio of the Number of flight takeoffs in Russian Federation in 2010 to that in 2011?
Provide a succinct answer. 0.88. What is the ratio of the Number of flight takeoffs of Slovak Republic in 2010 to that in 2011?
Your answer should be compact. 2.73. What is the ratio of the Number of flight takeoffs of Philippines in 2010 to that in 2012?
Make the answer very short. 0.85. What is the ratio of the Number of flight takeoffs of Russian Federation in 2010 to that in 2012?
Ensure brevity in your answer.  0.82. What is the ratio of the Number of flight takeoffs of Slovak Republic in 2010 to that in 2012?
Your answer should be very brief. 1.88. What is the ratio of the Number of flight takeoffs of Philippines in 2010 to that in 2013?
Your answer should be compact. 1.02. What is the ratio of the Number of flight takeoffs of Russian Federation in 2010 to that in 2013?
Provide a succinct answer. 0.77. What is the ratio of the Number of flight takeoffs in Slovak Republic in 2010 to that in 2013?
Make the answer very short. 1.49. What is the ratio of the Number of flight takeoffs in Philippines in 2011 to that in 2012?
Your answer should be very brief. 0.93. What is the ratio of the Number of flight takeoffs of Russian Federation in 2011 to that in 2012?
Offer a terse response. 0.94. What is the ratio of the Number of flight takeoffs of Slovak Republic in 2011 to that in 2012?
Ensure brevity in your answer.  0.69. What is the ratio of the Number of flight takeoffs of Philippines in 2011 to that in 2013?
Ensure brevity in your answer.  1.13. What is the ratio of the Number of flight takeoffs of Russian Federation in 2011 to that in 2013?
Give a very brief answer. 0.88. What is the ratio of the Number of flight takeoffs in Slovak Republic in 2011 to that in 2013?
Offer a terse response. 0.55. What is the ratio of the Number of flight takeoffs of Philippines in 2012 to that in 2013?
Your response must be concise. 1.21. What is the ratio of the Number of flight takeoffs of Russian Federation in 2012 to that in 2013?
Offer a terse response. 0.94. What is the ratio of the Number of flight takeoffs of Slovak Republic in 2012 to that in 2013?
Your answer should be very brief. 0.79. What is the difference between the highest and the second highest Number of flight takeoffs of Philippines?
Ensure brevity in your answer.  1.59e+04. What is the difference between the highest and the second highest Number of flight takeoffs in Russian Federation?
Your response must be concise. 4.13e+04. What is the difference between the highest and the second highest Number of flight takeoffs in Slovak Republic?
Your response must be concise. 7976. What is the difference between the highest and the lowest Number of flight takeoffs of Philippines?
Keep it short and to the point. 1.80e+05. What is the difference between the highest and the lowest Number of flight takeoffs of Russian Federation?
Your response must be concise. 2.57e+05. What is the difference between the highest and the lowest Number of flight takeoffs of Slovak Republic?
Give a very brief answer. 3.10e+04. 